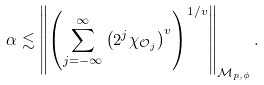<formula> <loc_0><loc_0><loc_500><loc_500>\alpha & \lesssim \left \| \left ( \sum _ { j = - \infty } ^ { \infty } \left ( 2 ^ { j } \chi _ { { \mathcal { O } } _ { j } } \right ) ^ { v } \right ) ^ { 1 / v } \right \| _ { { \mathcal { M } } _ { p , \phi } } .</formula> 